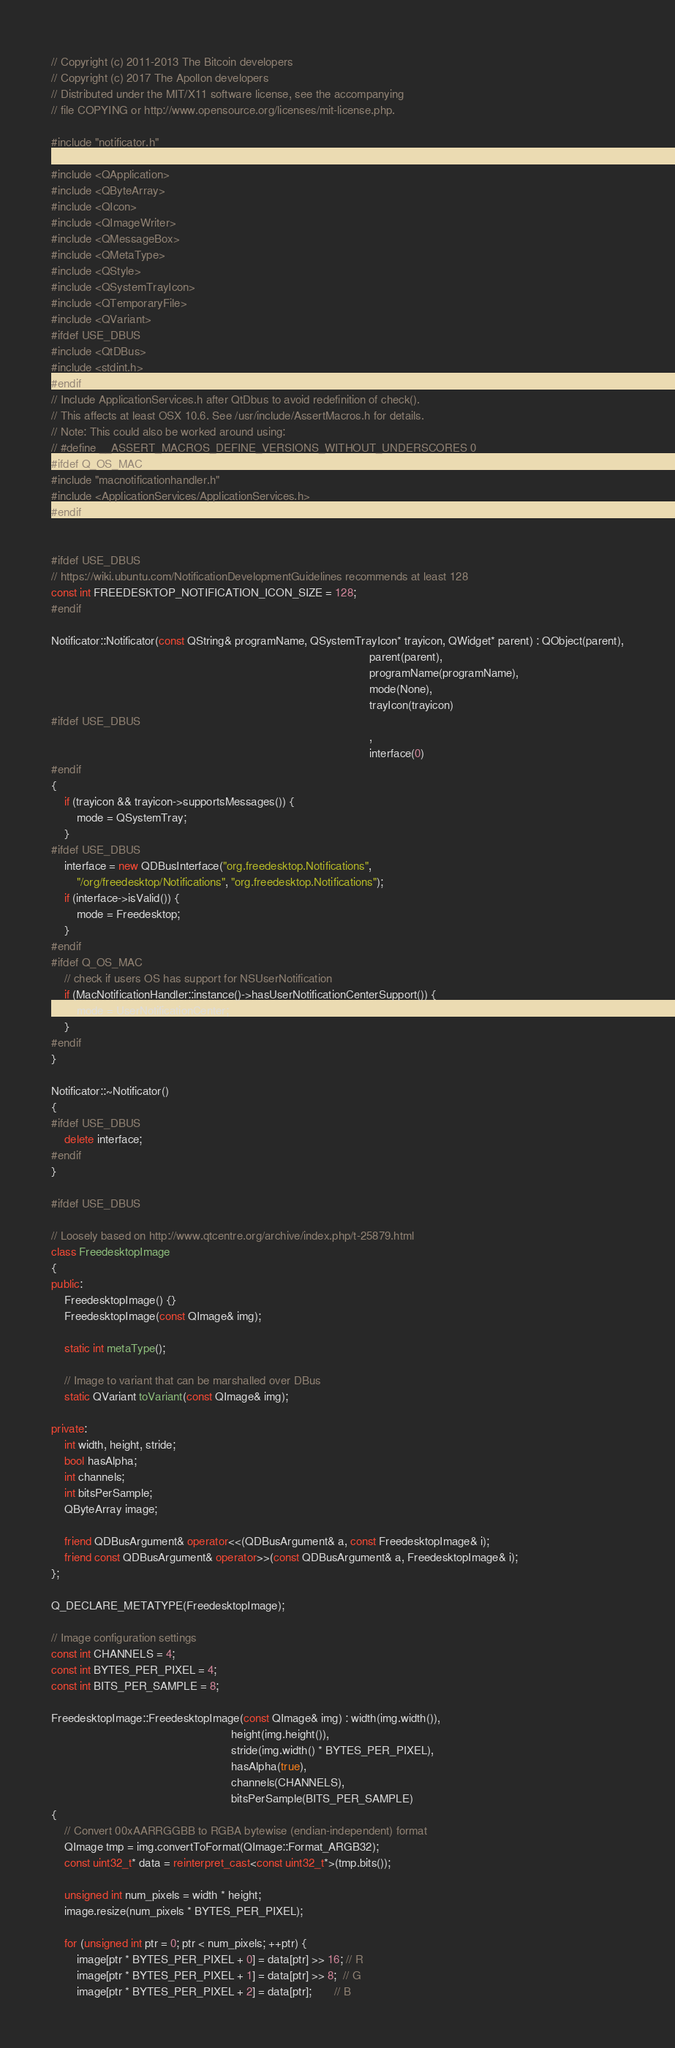<code> <loc_0><loc_0><loc_500><loc_500><_C++_>// Copyright (c) 2011-2013 The Bitcoin developers
// Copyright (c) 2017 The Apollon developers
// Distributed under the MIT/X11 software license, see the accompanying
// file COPYING or http://www.opensource.org/licenses/mit-license.php.

#include "notificator.h"

#include <QApplication>
#include <QByteArray>
#include <QIcon>
#include <QImageWriter>
#include <QMessageBox>
#include <QMetaType>
#include <QStyle>
#include <QSystemTrayIcon>
#include <QTemporaryFile>
#include <QVariant>
#ifdef USE_DBUS
#include <QtDBus>
#include <stdint.h>
#endif
// Include ApplicationServices.h after QtDbus to avoid redefinition of check().
// This affects at least OSX 10.6. See /usr/include/AssertMacros.h for details.
// Note: This could also be worked around using:
// #define __ASSERT_MACROS_DEFINE_VERSIONS_WITHOUT_UNDERSCORES 0
#ifdef Q_OS_MAC
#include "macnotificationhandler.h"
#include <ApplicationServices/ApplicationServices.h>
#endif


#ifdef USE_DBUS
// https://wiki.ubuntu.com/NotificationDevelopmentGuidelines recommends at least 128
const int FREEDESKTOP_NOTIFICATION_ICON_SIZE = 128;
#endif

Notificator::Notificator(const QString& programName, QSystemTrayIcon* trayicon, QWidget* parent) : QObject(parent),
                                                                                                   parent(parent),
                                                                                                   programName(programName),
                                                                                                   mode(None),
                                                                                                   trayIcon(trayicon)
#ifdef USE_DBUS
                                                                                                   ,
                                                                                                   interface(0)
#endif
{
    if (trayicon && trayicon->supportsMessages()) {
        mode = QSystemTray;
    }
#ifdef USE_DBUS
    interface = new QDBusInterface("org.freedesktop.Notifications",
        "/org/freedesktop/Notifications", "org.freedesktop.Notifications");
    if (interface->isValid()) {
        mode = Freedesktop;
    }
#endif
#ifdef Q_OS_MAC
    // check if users OS has support for NSUserNotification
    if (MacNotificationHandler::instance()->hasUserNotificationCenterSupport()) {
        mode = UserNotificationCenter;
    }
#endif
}

Notificator::~Notificator()
{
#ifdef USE_DBUS
    delete interface;
#endif
}

#ifdef USE_DBUS

// Loosely based on http://www.qtcentre.org/archive/index.php/t-25879.html
class FreedesktopImage
{
public:
    FreedesktopImage() {}
    FreedesktopImage(const QImage& img);

    static int metaType();

    // Image to variant that can be marshalled over DBus
    static QVariant toVariant(const QImage& img);

private:
    int width, height, stride;
    bool hasAlpha;
    int channels;
    int bitsPerSample;
    QByteArray image;

    friend QDBusArgument& operator<<(QDBusArgument& a, const FreedesktopImage& i);
    friend const QDBusArgument& operator>>(const QDBusArgument& a, FreedesktopImage& i);
};

Q_DECLARE_METATYPE(FreedesktopImage);

// Image configuration settings
const int CHANNELS = 4;
const int BYTES_PER_PIXEL = 4;
const int BITS_PER_SAMPLE = 8;

FreedesktopImage::FreedesktopImage(const QImage& img) : width(img.width()),
                                                        height(img.height()),
                                                        stride(img.width() * BYTES_PER_PIXEL),
                                                        hasAlpha(true),
                                                        channels(CHANNELS),
                                                        bitsPerSample(BITS_PER_SAMPLE)
{
    // Convert 00xAARRGGBB to RGBA bytewise (endian-independent) format
    QImage tmp = img.convertToFormat(QImage::Format_ARGB32);
    const uint32_t* data = reinterpret_cast<const uint32_t*>(tmp.bits());

    unsigned int num_pixels = width * height;
    image.resize(num_pixels * BYTES_PER_PIXEL);

    for (unsigned int ptr = 0; ptr < num_pixels; ++ptr) {
        image[ptr * BYTES_PER_PIXEL + 0] = data[ptr] >> 16; // R
        image[ptr * BYTES_PER_PIXEL + 1] = data[ptr] >> 8;  // G
        image[ptr * BYTES_PER_PIXEL + 2] = data[ptr];       // B</code> 